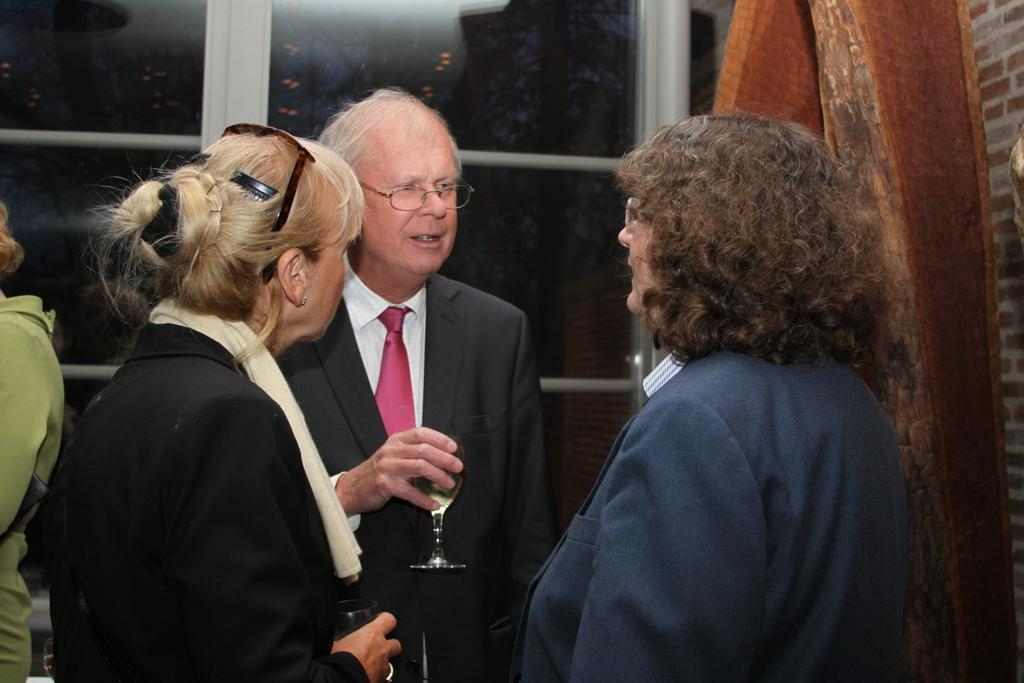How many people are in the group shown in the image? There is a group of people in the image, but the exact number is not specified. What are some of the people in the group holding? Some people in the group are holding drinking glasses. What type of windows can be seen in the image? There are glass windows visible in the image. What material is the wooden object made of? The wooden object in the image is made of wood. What type of vacation is the minister planning based on the image? There is no minister or vacation mentioned or depicted in the image. 